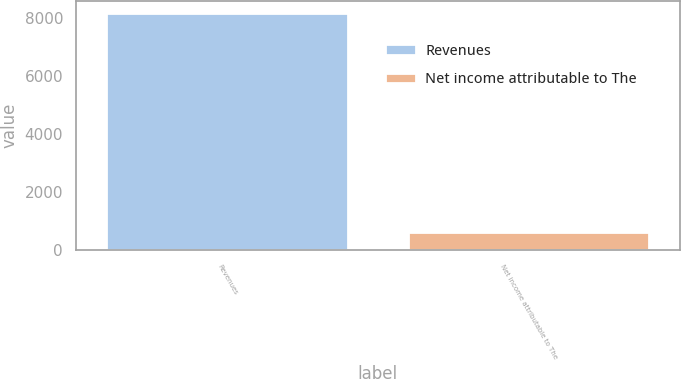Convert chart to OTSL. <chart><loc_0><loc_0><loc_500><loc_500><bar_chart><fcel>Revenues<fcel>Net income attributable to The<nl><fcel>8181<fcel>622<nl></chart> 